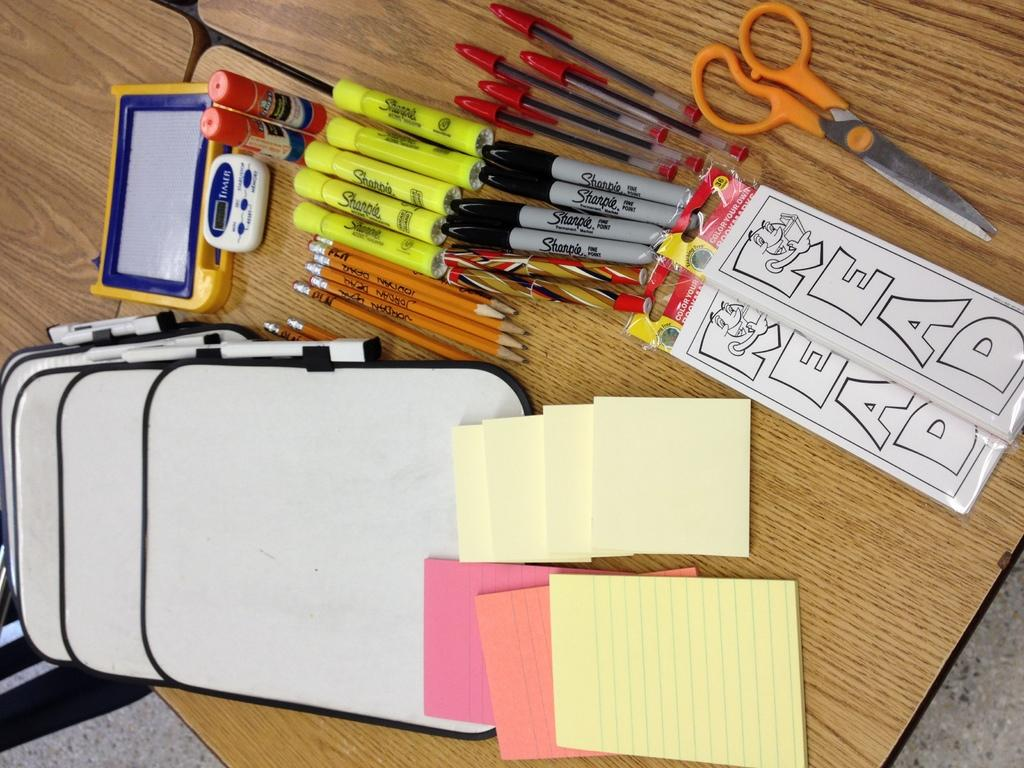<image>
Present a compact description of the photo's key features. Sharpie highlighters are on a table with other supplies. 